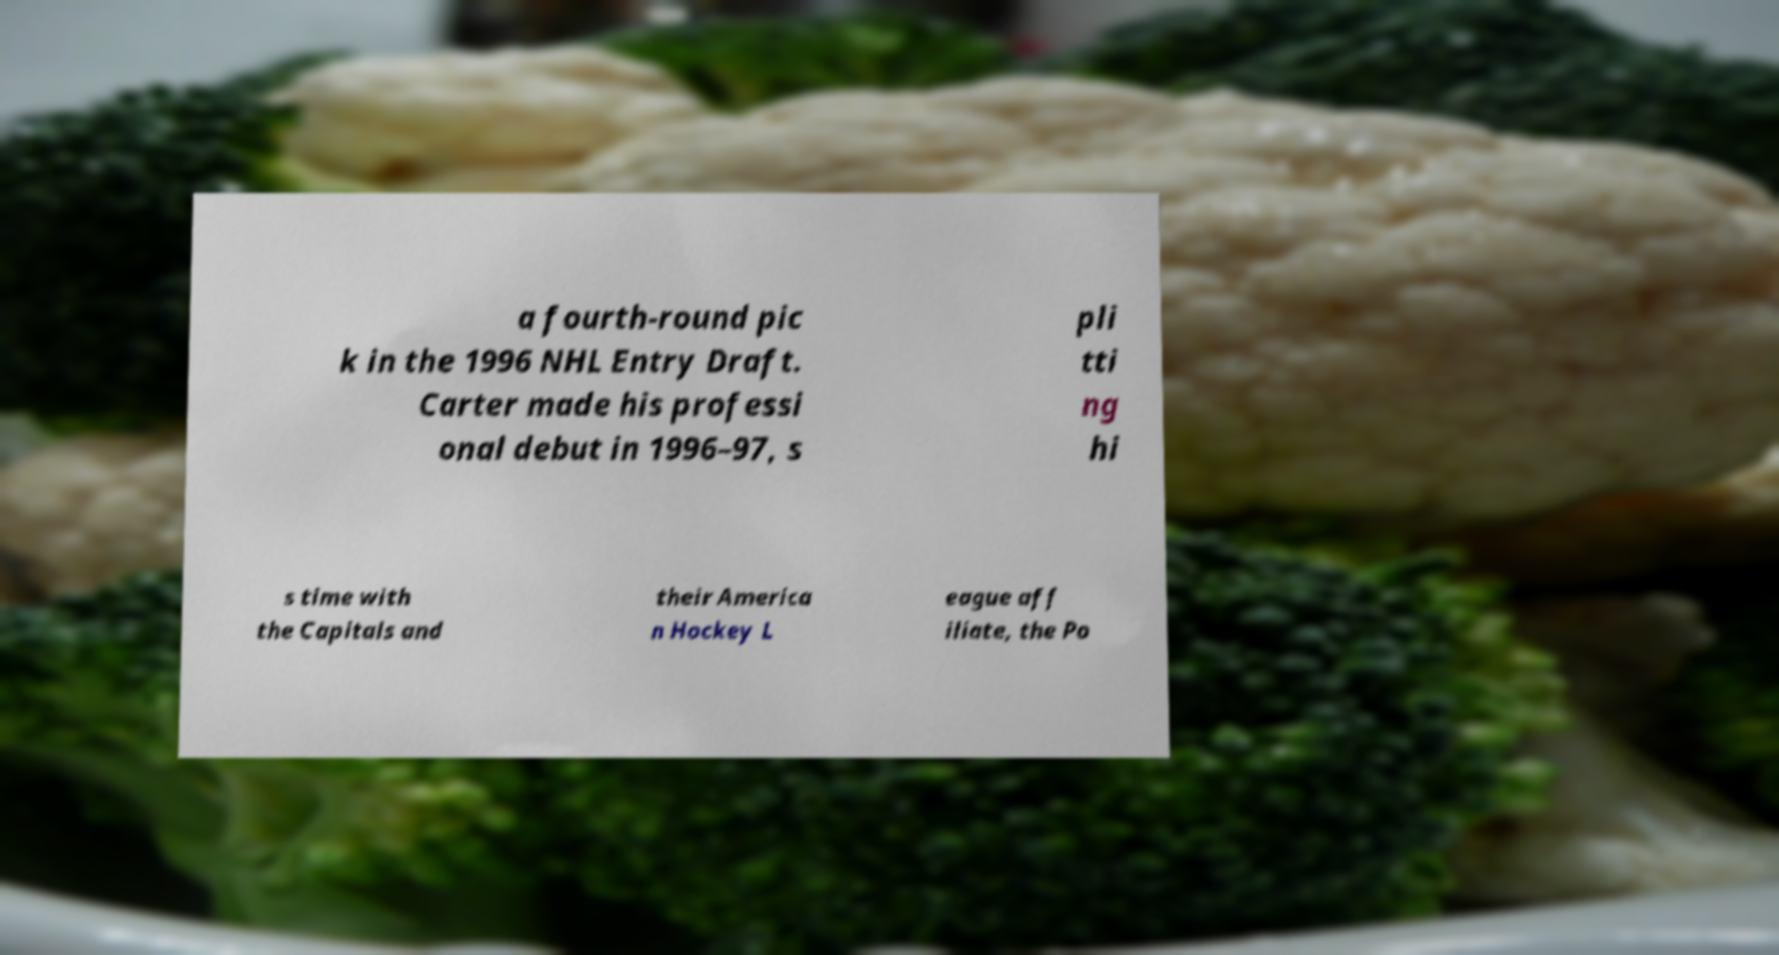There's text embedded in this image that I need extracted. Can you transcribe it verbatim? a fourth-round pic k in the 1996 NHL Entry Draft. Carter made his professi onal debut in 1996–97, s pli tti ng hi s time with the Capitals and their America n Hockey L eague aff iliate, the Po 